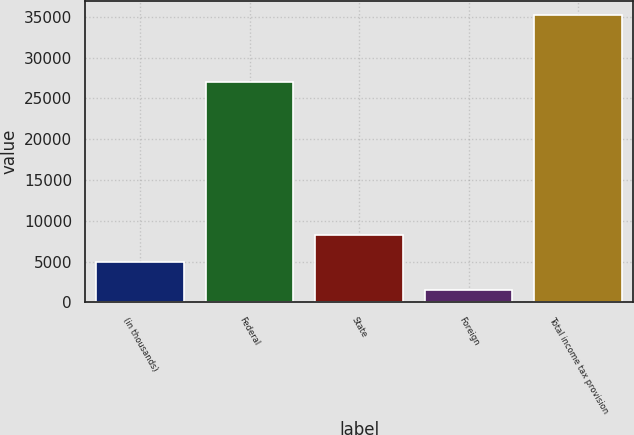<chart> <loc_0><loc_0><loc_500><loc_500><bar_chart><fcel>(in thousands)<fcel>Federal<fcel>State<fcel>Foreign<fcel>Total income tax provision<nl><fcel>4920.4<fcel>26973<fcel>8282.8<fcel>1558<fcel>35182<nl></chart> 